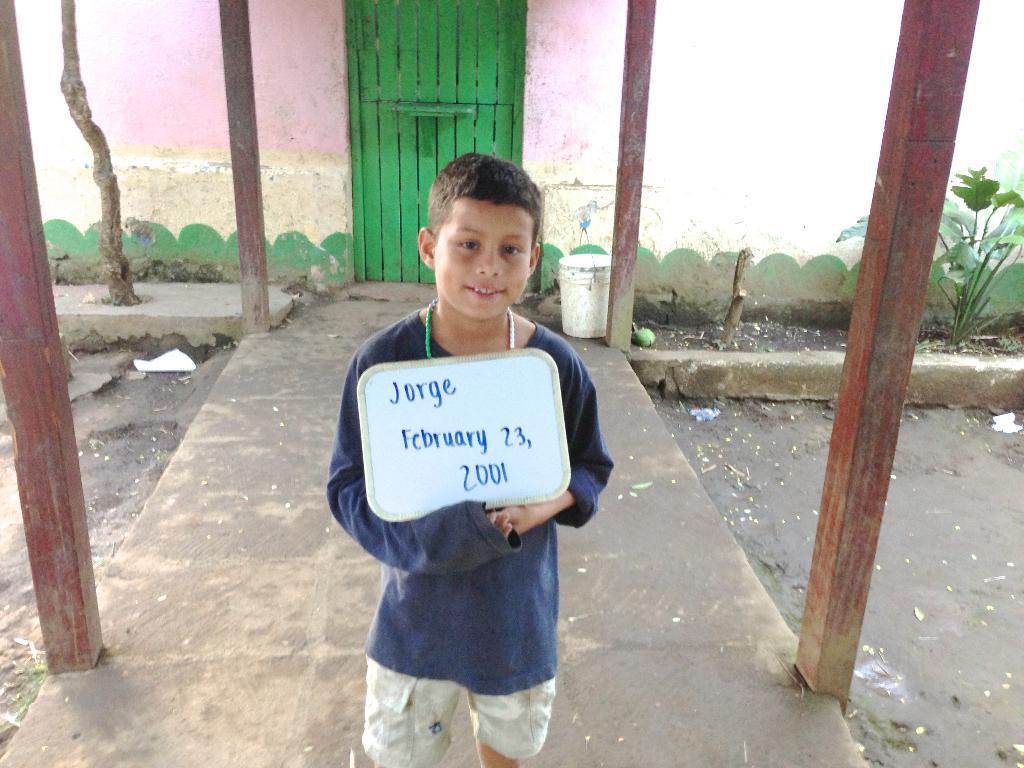Can you describe this image briefly? In this image we can see a boy holding the text board and standing and also smiling. In the background we can see the wall, green color bucket and also plant and tree. We can also the wooden pillars and also the path. 